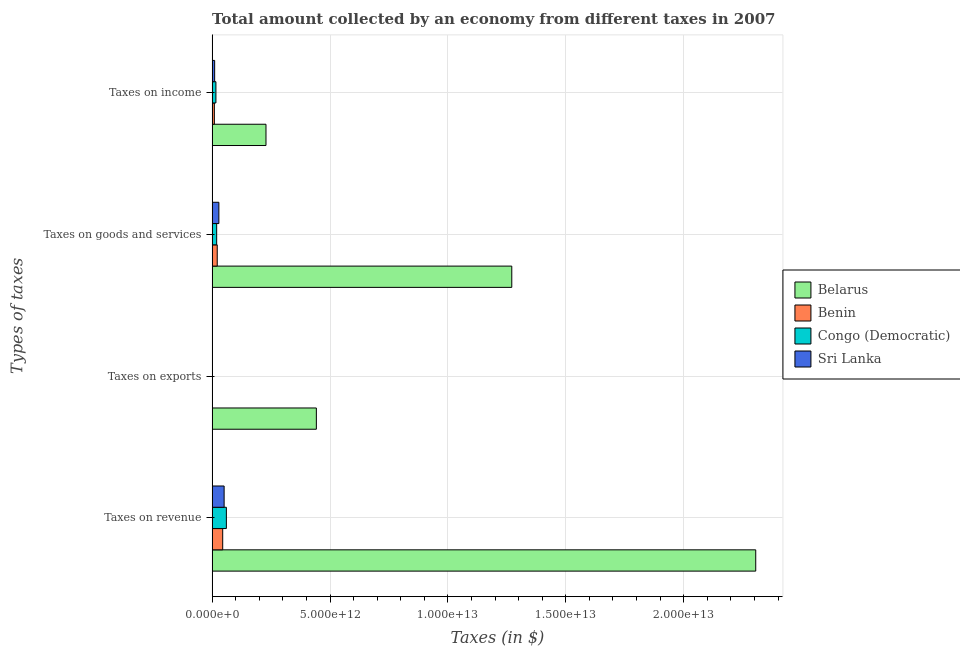How many groups of bars are there?
Make the answer very short. 4. Are the number of bars per tick equal to the number of legend labels?
Your answer should be compact. Yes. How many bars are there on the 2nd tick from the bottom?
Make the answer very short. 4. What is the label of the 3rd group of bars from the top?
Provide a succinct answer. Taxes on exports. What is the amount collected as tax on income in Congo (Democratic)?
Keep it short and to the point. 1.61e+11. Across all countries, what is the maximum amount collected as tax on exports?
Make the answer very short. 4.42e+12. Across all countries, what is the minimum amount collected as tax on exports?
Make the answer very short. 3.30e+07. In which country was the amount collected as tax on goods maximum?
Ensure brevity in your answer.  Belarus. In which country was the amount collected as tax on income minimum?
Make the answer very short. Benin. What is the total amount collected as tax on revenue in the graph?
Your answer should be very brief. 2.46e+13. What is the difference between the amount collected as tax on goods in Sri Lanka and that in Congo (Democratic)?
Your answer should be compact. 9.33e+1. What is the difference between the amount collected as tax on revenue in Benin and the amount collected as tax on income in Sri Lanka?
Give a very brief answer. 3.42e+11. What is the average amount collected as tax on exports per country?
Provide a short and direct response. 1.11e+12. What is the difference between the amount collected as tax on income and amount collected as tax on revenue in Congo (Democratic)?
Make the answer very short. -4.43e+11. In how many countries, is the amount collected as tax on goods greater than 23000000000000 $?
Keep it short and to the point. 0. What is the ratio of the amount collected as tax on income in Belarus to that in Congo (Democratic)?
Your response must be concise. 14.15. Is the difference between the amount collected as tax on goods in Benin and Congo (Democratic) greater than the difference between the amount collected as tax on income in Benin and Congo (Democratic)?
Give a very brief answer. Yes. What is the difference between the highest and the second highest amount collected as tax on exports?
Make the answer very short. 4.41e+12. What is the difference between the highest and the lowest amount collected as tax on exports?
Give a very brief answer. 4.42e+12. In how many countries, is the amount collected as tax on exports greater than the average amount collected as tax on exports taken over all countries?
Your answer should be very brief. 1. Is the sum of the amount collected as tax on exports in Belarus and Sri Lanka greater than the maximum amount collected as tax on income across all countries?
Your answer should be very brief. Yes. Is it the case that in every country, the sum of the amount collected as tax on goods and amount collected as tax on income is greater than the sum of amount collected as tax on revenue and amount collected as tax on exports?
Offer a very short reply. Yes. What does the 2nd bar from the top in Taxes on goods and services represents?
Offer a very short reply. Congo (Democratic). What does the 3rd bar from the bottom in Taxes on goods and services represents?
Your response must be concise. Congo (Democratic). What is the difference between two consecutive major ticks on the X-axis?
Keep it short and to the point. 5.00e+12. What is the title of the graph?
Offer a terse response. Total amount collected by an economy from different taxes in 2007. What is the label or title of the X-axis?
Provide a short and direct response. Taxes (in $). What is the label or title of the Y-axis?
Offer a terse response. Types of taxes. What is the Taxes (in $) in Belarus in Taxes on revenue?
Make the answer very short. 2.31e+13. What is the Taxes (in $) of Benin in Taxes on revenue?
Keep it short and to the point. 4.49e+11. What is the Taxes (in $) in Congo (Democratic) in Taxes on revenue?
Provide a short and direct response. 6.05e+11. What is the Taxes (in $) of Sri Lanka in Taxes on revenue?
Provide a succinct answer. 5.09e+11. What is the Taxes (in $) of Belarus in Taxes on exports?
Make the answer very short. 4.42e+12. What is the Taxes (in $) in Benin in Taxes on exports?
Your answer should be very brief. 2.34e+09. What is the Taxes (in $) in Congo (Democratic) in Taxes on exports?
Give a very brief answer. 8.68e+09. What is the Taxes (in $) of Sri Lanka in Taxes on exports?
Offer a terse response. 3.30e+07. What is the Taxes (in $) in Belarus in Taxes on goods and services?
Keep it short and to the point. 1.27e+13. What is the Taxes (in $) of Benin in Taxes on goods and services?
Your response must be concise. 2.16e+11. What is the Taxes (in $) in Congo (Democratic) in Taxes on goods and services?
Ensure brevity in your answer.  1.93e+11. What is the Taxes (in $) in Sri Lanka in Taxes on goods and services?
Your response must be concise. 2.86e+11. What is the Taxes (in $) of Belarus in Taxes on income?
Ensure brevity in your answer.  2.28e+12. What is the Taxes (in $) of Benin in Taxes on income?
Provide a succinct answer. 9.47e+1. What is the Taxes (in $) of Congo (Democratic) in Taxes on income?
Your answer should be compact. 1.61e+11. What is the Taxes (in $) of Sri Lanka in Taxes on income?
Provide a short and direct response. 1.07e+11. Across all Types of taxes, what is the maximum Taxes (in $) of Belarus?
Ensure brevity in your answer.  2.31e+13. Across all Types of taxes, what is the maximum Taxes (in $) of Benin?
Offer a very short reply. 4.49e+11. Across all Types of taxes, what is the maximum Taxes (in $) in Congo (Democratic)?
Your response must be concise. 6.05e+11. Across all Types of taxes, what is the maximum Taxes (in $) of Sri Lanka?
Make the answer very short. 5.09e+11. Across all Types of taxes, what is the minimum Taxes (in $) of Belarus?
Your answer should be very brief. 2.28e+12. Across all Types of taxes, what is the minimum Taxes (in $) of Benin?
Provide a short and direct response. 2.34e+09. Across all Types of taxes, what is the minimum Taxes (in $) in Congo (Democratic)?
Provide a succinct answer. 8.68e+09. Across all Types of taxes, what is the minimum Taxes (in $) in Sri Lanka?
Make the answer very short. 3.30e+07. What is the total Taxes (in $) in Belarus in the graph?
Give a very brief answer. 4.25e+13. What is the total Taxes (in $) of Benin in the graph?
Ensure brevity in your answer.  7.63e+11. What is the total Taxes (in $) in Congo (Democratic) in the graph?
Your answer should be compact. 9.68e+11. What is the total Taxes (in $) in Sri Lanka in the graph?
Your answer should be compact. 9.02e+11. What is the difference between the Taxes (in $) in Belarus in Taxes on revenue and that in Taxes on exports?
Keep it short and to the point. 1.86e+13. What is the difference between the Taxes (in $) in Benin in Taxes on revenue and that in Taxes on exports?
Your response must be concise. 4.47e+11. What is the difference between the Taxes (in $) in Congo (Democratic) in Taxes on revenue and that in Taxes on exports?
Provide a short and direct response. 5.96e+11. What is the difference between the Taxes (in $) in Sri Lanka in Taxes on revenue and that in Taxes on exports?
Your answer should be compact. 5.09e+11. What is the difference between the Taxes (in $) in Belarus in Taxes on revenue and that in Taxes on goods and services?
Your answer should be compact. 1.03e+13. What is the difference between the Taxes (in $) of Benin in Taxes on revenue and that in Taxes on goods and services?
Give a very brief answer. 2.33e+11. What is the difference between the Taxes (in $) of Congo (Democratic) in Taxes on revenue and that in Taxes on goods and services?
Offer a terse response. 4.12e+11. What is the difference between the Taxes (in $) of Sri Lanka in Taxes on revenue and that in Taxes on goods and services?
Ensure brevity in your answer.  2.23e+11. What is the difference between the Taxes (in $) in Belarus in Taxes on revenue and that in Taxes on income?
Offer a very short reply. 2.08e+13. What is the difference between the Taxes (in $) in Benin in Taxes on revenue and that in Taxes on income?
Offer a terse response. 3.54e+11. What is the difference between the Taxes (in $) of Congo (Democratic) in Taxes on revenue and that in Taxes on income?
Ensure brevity in your answer.  4.43e+11. What is the difference between the Taxes (in $) in Sri Lanka in Taxes on revenue and that in Taxes on income?
Provide a short and direct response. 4.02e+11. What is the difference between the Taxes (in $) in Belarus in Taxes on exports and that in Taxes on goods and services?
Keep it short and to the point. -8.29e+12. What is the difference between the Taxes (in $) of Benin in Taxes on exports and that in Taxes on goods and services?
Offer a very short reply. -2.14e+11. What is the difference between the Taxes (in $) in Congo (Democratic) in Taxes on exports and that in Taxes on goods and services?
Provide a succinct answer. -1.84e+11. What is the difference between the Taxes (in $) of Sri Lanka in Taxes on exports and that in Taxes on goods and services?
Provide a short and direct response. -2.86e+11. What is the difference between the Taxes (in $) of Belarus in Taxes on exports and that in Taxes on income?
Provide a short and direct response. 2.14e+12. What is the difference between the Taxes (in $) of Benin in Taxes on exports and that in Taxes on income?
Give a very brief answer. -9.24e+1. What is the difference between the Taxes (in $) in Congo (Democratic) in Taxes on exports and that in Taxes on income?
Provide a short and direct response. -1.53e+11. What is the difference between the Taxes (in $) of Sri Lanka in Taxes on exports and that in Taxes on income?
Keep it short and to the point. -1.07e+11. What is the difference between the Taxes (in $) in Belarus in Taxes on goods and services and that in Taxes on income?
Provide a succinct answer. 1.04e+13. What is the difference between the Taxes (in $) of Benin in Taxes on goods and services and that in Taxes on income?
Ensure brevity in your answer.  1.22e+11. What is the difference between the Taxes (in $) in Congo (Democratic) in Taxes on goods and services and that in Taxes on income?
Your answer should be compact. 3.15e+1. What is the difference between the Taxes (in $) of Sri Lanka in Taxes on goods and services and that in Taxes on income?
Offer a terse response. 1.79e+11. What is the difference between the Taxes (in $) of Belarus in Taxes on revenue and the Taxes (in $) of Benin in Taxes on exports?
Your response must be concise. 2.31e+13. What is the difference between the Taxes (in $) of Belarus in Taxes on revenue and the Taxes (in $) of Congo (Democratic) in Taxes on exports?
Give a very brief answer. 2.30e+13. What is the difference between the Taxes (in $) in Belarus in Taxes on revenue and the Taxes (in $) in Sri Lanka in Taxes on exports?
Provide a short and direct response. 2.31e+13. What is the difference between the Taxes (in $) of Benin in Taxes on revenue and the Taxes (in $) of Congo (Democratic) in Taxes on exports?
Keep it short and to the point. 4.40e+11. What is the difference between the Taxes (in $) of Benin in Taxes on revenue and the Taxes (in $) of Sri Lanka in Taxes on exports?
Your response must be concise. 4.49e+11. What is the difference between the Taxes (in $) of Congo (Democratic) in Taxes on revenue and the Taxes (in $) of Sri Lanka in Taxes on exports?
Provide a short and direct response. 6.05e+11. What is the difference between the Taxes (in $) of Belarus in Taxes on revenue and the Taxes (in $) of Benin in Taxes on goods and services?
Give a very brief answer. 2.28e+13. What is the difference between the Taxes (in $) in Belarus in Taxes on revenue and the Taxes (in $) in Congo (Democratic) in Taxes on goods and services?
Your response must be concise. 2.29e+13. What is the difference between the Taxes (in $) in Belarus in Taxes on revenue and the Taxes (in $) in Sri Lanka in Taxes on goods and services?
Keep it short and to the point. 2.28e+13. What is the difference between the Taxes (in $) in Benin in Taxes on revenue and the Taxes (in $) in Congo (Democratic) in Taxes on goods and services?
Provide a short and direct response. 2.56e+11. What is the difference between the Taxes (in $) of Benin in Taxes on revenue and the Taxes (in $) of Sri Lanka in Taxes on goods and services?
Provide a short and direct response. 1.63e+11. What is the difference between the Taxes (in $) of Congo (Democratic) in Taxes on revenue and the Taxes (in $) of Sri Lanka in Taxes on goods and services?
Provide a succinct answer. 3.19e+11. What is the difference between the Taxes (in $) of Belarus in Taxes on revenue and the Taxes (in $) of Benin in Taxes on income?
Your answer should be compact. 2.30e+13. What is the difference between the Taxes (in $) of Belarus in Taxes on revenue and the Taxes (in $) of Congo (Democratic) in Taxes on income?
Provide a short and direct response. 2.29e+13. What is the difference between the Taxes (in $) of Belarus in Taxes on revenue and the Taxes (in $) of Sri Lanka in Taxes on income?
Give a very brief answer. 2.29e+13. What is the difference between the Taxes (in $) in Benin in Taxes on revenue and the Taxes (in $) in Congo (Democratic) in Taxes on income?
Keep it short and to the point. 2.88e+11. What is the difference between the Taxes (in $) in Benin in Taxes on revenue and the Taxes (in $) in Sri Lanka in Taxes on income?
Provide a short and direct response. 3.42e+11. What is the difference between the Taxes (in $) of Congo (Democratic) in Taxes on revenue and the Taxes (in $) of Sri Lanka in Taxes on income?
Offer a very short reply. 4.98e+11. What is the difference between the Taxes (in $) of Belarus in Taxes on exports and the Taxes (in $) of Benin in Taxes on goods and services?
Your response must be concise. 4.20e+12. What is the difference between the Taxes (in $) of Belarus in Taxes on exports and the Taxes (in $) of Congo (Democratic) in Taxes on goods and services?
Your answer should be compact. 4.23e+12. What is the difference between the Taxes (in $) of Belarus in Taxes on exports and the Taxes (in $) of Sri Lanka in Taxes on goods and services?
Offer a very short reply. 4.13e+12. What is the difference between the Taxes (in $) of Benin in Taxes on exports and the Taxes (in $) of Congo (Democratic) in Taxes on goods and services?
Provide a short and direct response. -1.90e+11. What is the difference between the Taxes (in $) of Benin in Taxes on exports and the Taxes (in $) of Sri Lanka in Taxes on goods and services?
Provide a succinct answer. -2.84e+11. What is the difference between the Taxes (in $) in Congo (Democratic) in Taxes on exports and the Taxes (in $) in Sri Lanka in Taxes on goods and services?
Make the answer very short. -2.77e+11. What is the difference between the Taxes (in $) of Belarus in Taxes on exports and the Taxes (in $) of Benin in Taxes on income?
Your answer should be very brief. 4.33e+12. What is the difference between the Taxes (in $) in Belarus in Taxes on exports and the Taxes (in $) in Congo (Democratic) in Taxes on income?
Provide a short and direct response. 4.26e+12. What is the difference between the Taxes (in $) in Belarus in Taxes on exports and the Taxes (in $) in Sri Lanka in Taxes on income?
Your answer should be compact. 4.31e+12. What is the difference between the Taxes (in $) of Benin in Taxes on exports and the Taxes (in $) of Congo (Democratic) in Taxes on income?
Your answer should be very brief. -1.59e+11. What is the difference between the Taxes (in $) of Benin in Taxes on exports and the Taxes (in $) of Sri Lanka in Taxes on income?
Your response must be concise. -1.05e+11. What is the difference between the Taxes (in $) of Congo (Democratic) in Taxes on exports and the Taxes (in $) of Sri Lanka in Taxes on income?
Make the answer very short. -9.85e+1. What is the difference between the Taxes (in $) in Belarus in Taxes on goods and services and the Taxes (in $) in Benin in Taxes on income?
Give a very brief answer. 1.26e+13. What is the difference between the Taxes (in $) in Belarus in Taxes on goods and services and the Taxes (in $) in Congo (Democratic) in Taxes on income?
Give a very brief answer. 1.25e+13. What is the difference between the Taxes (in $) of Belarus in Taxes on goods and services and the Taxes (in $) of Sri Lanka in Taxes on income?
Ensure brevity in your answer.  1.26e+13. What is the difference between the Taxes (in $) in Benin in Taxes on goods and services and the Taxes (in $) in Congo (Democratic) in Taxes on income?
Provide a short and direct response. 5.51e+1. What is the difference between the Taxes (in $) in Benin in Taxes on goods and services and the Taxes (in $) in Sri Lanka in Taxes on income?
Offer a terse response. 1.09e+11. What is the difference between the Taxes (in $) of Congo (Democratic) in Taxes on goods and services and the Taxes (in $) of Sri Lanka in Taxes on income?
Ensure brevity in your answer.  8.57e+1. What is the average Taxes (in $) of Belarus per Types of taxes?
Offer a very short reply. 1.06e+13. What is the average Taxes (in $) of Benin per Types of taxes?
Provide a short and direct response. 1.91e+11. What is the average Taxes (in $) of Congo (Democratic) per Types of taxes?
Provide a succinct answer. 2.42e+11. What is the average Taxes (in $) in Sri Lanka per Types of taxes?
Ensure brevity in your answer.  2.26e+11. What is the difference between the Taxes (in $) of Belarus and Taxes (in $) of Benin in Taxes on revenue?
Your answer should be very brief. 2.26e+13. What is the difference between the Taxes (in $) of Belarus and Taxes (in $) of Congo (Democratic) in Taxes on revenue?
Your response must be concise. 2.24e+13. What is the difference between the Taxes (in $) in Belarus and Taxes (in $) in Sri Lanka in Taxes on revenue?
Offer a terse response. 2.25e+13. What is the difference between the Taxes (in $) in Benin and Taxes (in $) in Congo (Democratic) in Taxes on revenue?
Your answer should be compact. -1.56e+11. What is the difference between the Taxes (in $) of Benin and Taxes (in $) of Sri Lanka in Taxes on revenue?
Keep it short and to the point. -5.99e+1. What is the difference between the Taxes (in $) in Congo (Democratic) and Taxes (in $) in Sri Lanka in Taxes on revenue?
Your answer should be compact. 9.58e+1. What is the difference between the Taxes (in $) of Belarus and Taxes (in $) of Benin in Taxes on exports?
Keep it short and to the point. 4.42e+12. What is the difference between the Taxes (in $) of Belarus and Taxes (in $) of Congo (Democratic) in Taxes on exports?
Your answer should be compact. 4.41e+12. What is the difference between the Taxes (in $) of Belarus and Taxes (in $) of Sri Lanka in Taxes on exports?
Offer a terse response. 4.42e+12. What is the difference between the Taxes (in $) in Benin and Taxes (in $) in Congo (Democratic) in Taxes on exports?
Your answer should be compact. -6.34e+09. What is the difference between the Taxes (in $) in Benin and Taxes (in $) in Sri Lanka in Taxes on exports?
Offer a very short reply. 2.31e+09. What is the difference between the Taxes (in $) of Congo (Democratic) and Taxes (in $) of Sri Lanka in Taxes on exports?
Your answer should be very brief. 8.65e+09. What is the difference between the Taxes (in $) in Belarus and Taxes (in $) in Benin in Taxes on goods and services?
Your answer should be compact. 1.25e+13. What is the difference between the Taxes (in $) of Belarus and Taxes (in $) of Congo (Democratic) in Taxes on goods and services?
Your answer should be compact. 1.25e+13. What is the difference between the Taxes (in $) of Belarus and Taxes (in $) of Sri Lanka in Taxes on goods and services?
Your response must be concise. 1.24e+13. What is the difference between the Taxes (in $) in Benin and Taxes (in $) in Congo (Democratic) in Taxes on goods and services?
Ensure brevity in your answer.  2.36e+1. What is the difference between the Taxes (in $) of Benin and Taxes (in $) of Sri Lanka in Taxes on goods and services?
Provide a succinct answer. -6.97e+1. What is the difference between the Taxes (in $) of Congo (Democratic) and Taxes (in $) of Sri Lanka in Taxes on goods and services?
Your answer should be very brief. -9.33e+1. What is the difference between the Taxes (in $) of Belarus and Taxes (in $) of Benin in Taxes on income?
Your answer should be very brief. 2.19e+12. What is the difference between the Taxes (in $) of Belarus and Taxes (in $) of Congo (Democratic) in Taxes on income?
Offer a terse response. 2.12e+12. What is the difference between the Taxes (in $) of Belarus and Taxes (in $) of Sri Lanka in Taxes on income?
Provide a short and direct response. 2.18e+12. What is the difference between the Taxes (in $) in Benin and Taxes (in $) in Congo (Democratic) in Taxes on income?
Keep it short and to the point. -6.67e+1. What is the difference between the Taxes (in $) in Benin and Taxes (in $) in Sri Lanka in Taxes on income?
Offer a very short reply. -1.25e+1. What is the difference between the Taxes (in $) in Congo (Democratic) and Taxes (in $) in Sri Lanka in Taxes on income?
Offer a very short reply. 5.42e+1. What is the ratio of the Taxes (in $) of Belarus in Taxes on revenue to that in Taxes on exports?
Make the answer very short. 5.22. What is the ratio of the Taxes (in $) of Benin in Taxes on revenue to that in Taxes on exports?
Offer a very short reply. 192. What is the ratio of the Taxes (in $) of Congo (Democratic) in Taxes on revenue to that in Taxes on exports?
Offer a very short reply. 69.68. What is the ratio of the Taxes (in $) in Sri Lanka in Taxes on revenue to that in Taxes on exports?
Give a very brief answer. 1.54e+04. What is the ratio of the Taxes (in $) in Belarus in Taxes on revenue to that in Taxes on goods and services?
Your answer should be very brief. 1.81. What is the ratio of the Taxes (in $) of Benin in Taxes on revenue to that in Taxes on goods and services?
Your response must be concise. 2.07. What is the ratio of the Taxes (in $) of Congo (Democratic) in Taxes on revenue to that in Taxes on goods and services?
Offer a terse response. 3.14. What is the ratio of the Taxes (in $) in Sri Lanka in Taxes on revenue to that in Taxes on goods and services?
Provide a succinct answer. 1.78. What is the ratio of the Taxes (in $) of Belarus in Taxes on revenue to that in Taxes on income?
Provide a short and direct response. 10.09. What is the ratio of the Taxes (in $) in Benin in Taxes on revenue to that in Taxes on income?
Your answer should be compact. 4.74. What is the ratio of the Taxes (in $) in Congo (Democratic) in Taxes on revenue to that in Taxes on income?
Give a very brief answer. 3.75. What is the ratio of the Taxes (in $) of Sri Lanka in Taxes on revenue to that in Taxes on income?
Keep it short and to the point. 4.75. What is the ratio of the Taxes (in $) of Belarus in Taxes on exports to that in Taxes on goods and services?
Offer a terse response. 0.35. What is the ratio of the Taxes (in $) of Benin in Taxes on exports to that in Taxes on goods and services?
Offer a very short reply. 0.01. What is the ratio of the Taxes (in $) in Congo (Democratic) in Taxes on exports to that in Taxes on goods and services?
Your answer should be compact. 0.04. What is the ratio of the Taxes (in $) of Sri Lanka in Taxes on exports to that in Taxes on goods and services?
Your response must be concise. 0. What is the ratio of the Taxes (in $) of Belarus in Taxes on exports to that in Taxes on income?
Provide a succinct answer. 1.94. What is the ratio of the Taxes (in $) of Benin in Taxes on exports to that in Taxes on income?
Offer a terse response. 0.02. What is the ratio of the Taxes (in $) of Congo (Democratic) in Taxes on exports to that in Taxes on income?
Ensure brevity in your answer.  0.05. What is the ratio of the Taxes (in $) of Belarus in Taxes on goods and services to that in Taxes on income?
Keep it short and to the point. 5.56. What is the ratio of the Taxes (in $) in Benin in Taxes on goods and services to that in Taxes on income?
Give a very brief answer. 2.29. What is the ratio of the Taxes (in $) of Congo (Democratic) in Taxes on goods and services to that in Taxes on income?
Make the answer very short. 1.2. What is the ratio of the Taxes (in $) of Sri Lanka in Taxes on goods and services to that in Taxes on income?
Ensure brevity in your answer.  2.67. What is the difference between the highest and the second highest Taxes (in $) in Belarus?
Give a very brief answer. 1.03e+13. What is the difference between the highest and the second highest Taxes (in $) of Benin?
Make the answer very short. 2.33e+11. What is the difference between the highest and the second highest Taxes (in $) of Congo (Democratic)?
Your response must be concise. 4.12e+11. What is the difference between the highest and the second highest Taxes (in $) of Sri Lanka?
Make the answer very short. 2.23e+11. What is the difference between the highest and the lowest Taxes (in $) in Belarus?
Ensure brevity in your answer.  2.08e+13. What is the difference between the highest and the lowest Taxes (in $) of Benin?
Offer a very short reply. 4.47e+11. What is the difference between the highest and the lowest Taxes (in $) of Congo (Democratic)?
Offer a very short reply. 5.96e+11. What is the difference between the highest and the lowest Taxes (in $) of Sri Lanka?
Offer a terse response. 5.09e+11. 